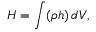<formula> <loc_0><loc_0><loc_500><loc_500>H = \int ( \rho h ) \, d V ,</formula> 